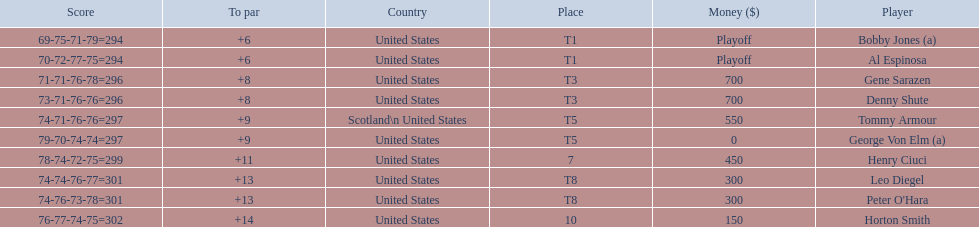Who was the last player in the top 10? Horton Smith. 